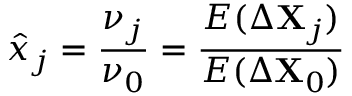Convert formula to latex. <formula><loc_0><loc_0><loc_500><loc_500>\hat { x } _ { j } = \frac { \nu _ { j } } { \nu _ { 0 } } = \frac { E ( \Delta X _ { j } ) } { E ( \Delta X _ { 0 } ) }</formula> 